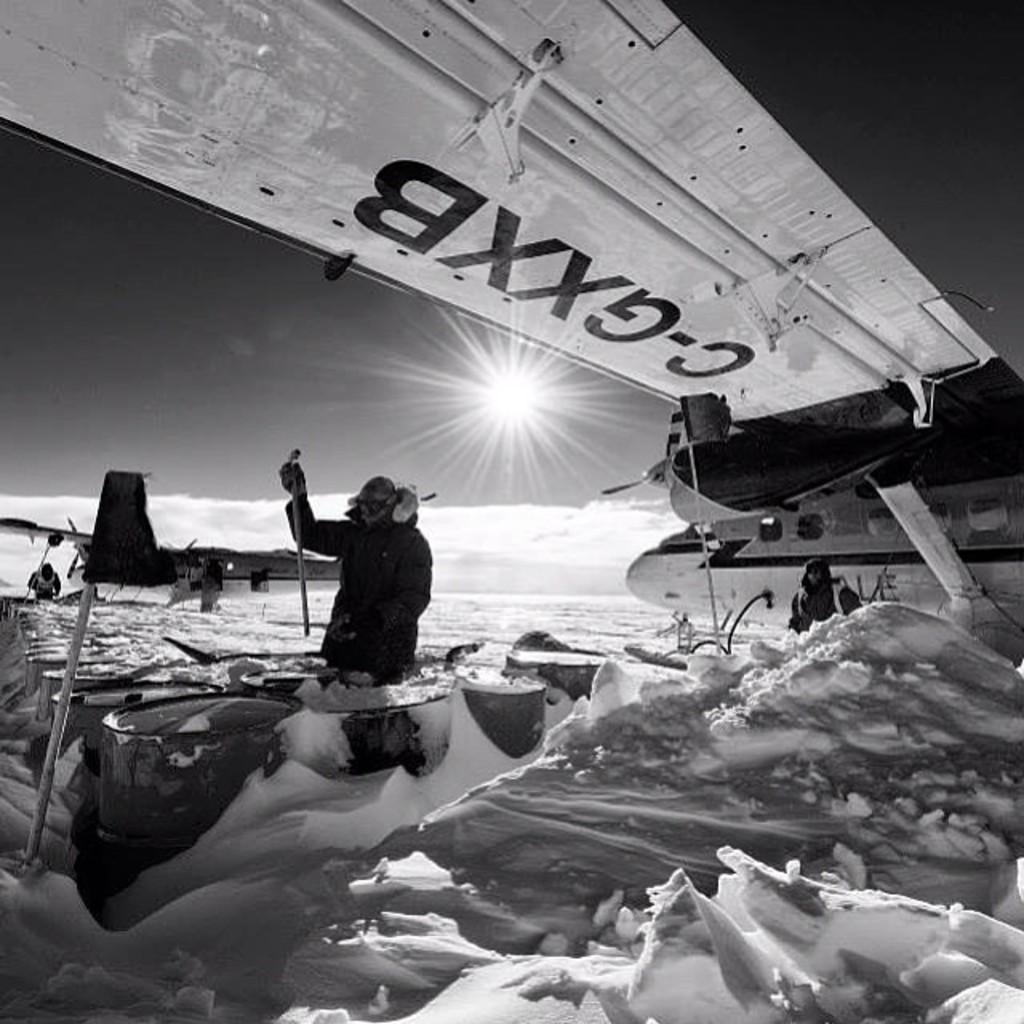<image>
Provide a brief description of the given image. A man in the snow under the wing of an aeroplane with the number C-GXXB on it 